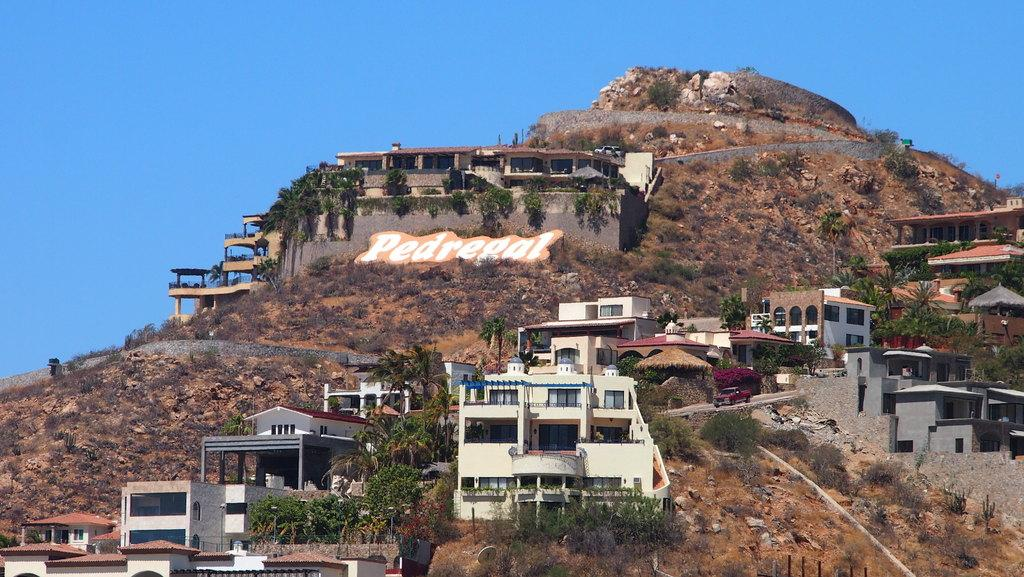What is the main feature of the image? There is a huge mountain in the image. What can be seen on the mountain? There are buildings, trees, and vehicles on the mountain. What is visible in the background of the image? The sky is visible in the background of the image. How much sugar is present in the image? There is no sugar present in the image, as it features a mountain with buildings, trees, and vehicles. What type of cap is the partner wearing in the image? There is no partner or cap present in the image; it only shows a mountain with various elements on it. 